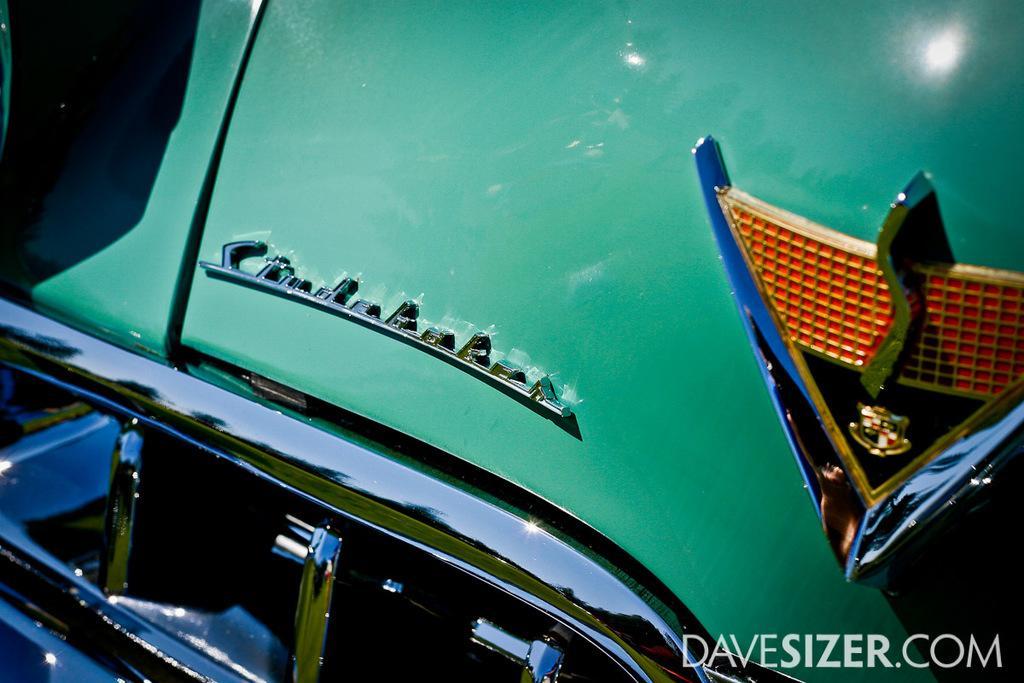Could you give a brief overview of what you see in this image? It is a zoomed in picture of a green color car and in the bottom right corner there is text. 